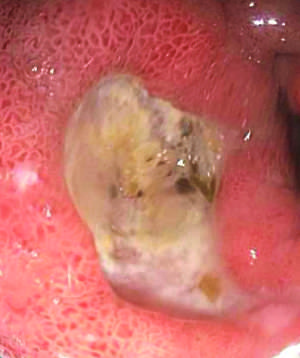what is associated with nsaid use?
Answer the question using a single word or phrase. Typical antral ulcer 